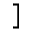Convert formula to latex. <formula><loc_0><loc_0><loc_500><loc_500>]</formula> 